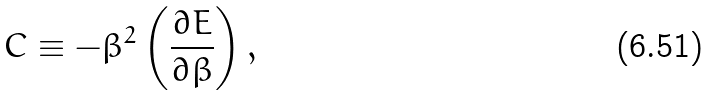Convert formula to latex. <formula><loc_0><loc_0><loc_500><loc_500>C \equiv - \beta ^ { 2 } \left ( { \frac { \partial E } { \partial \beta } } \right ) ,</formula> 